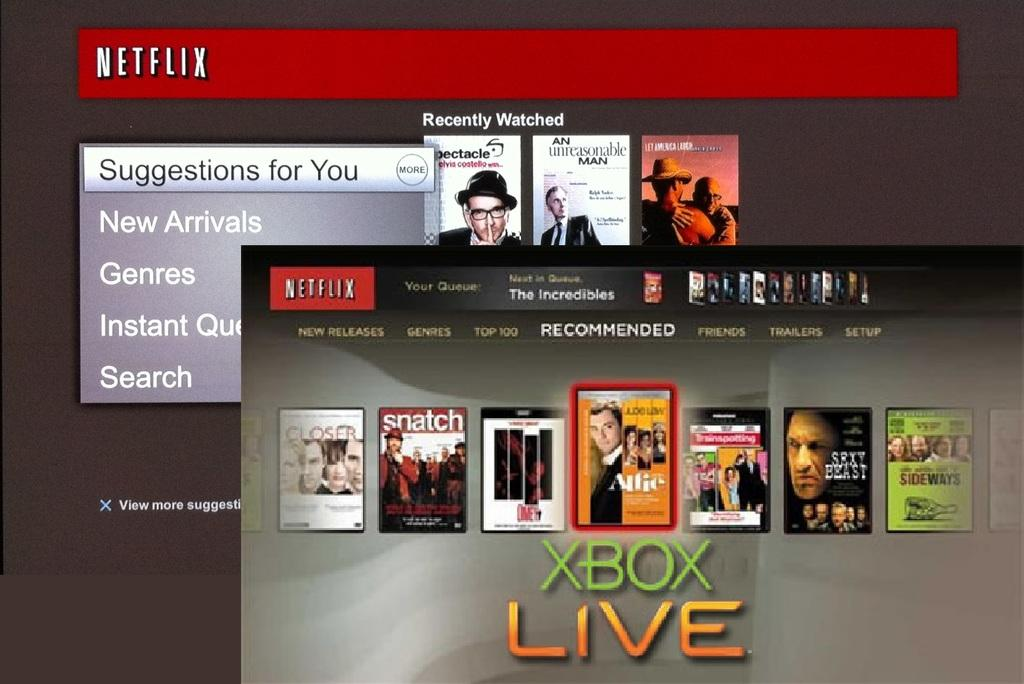<image>
Write a terse but informative summary of the picture. an xbox live screen with movies on it 